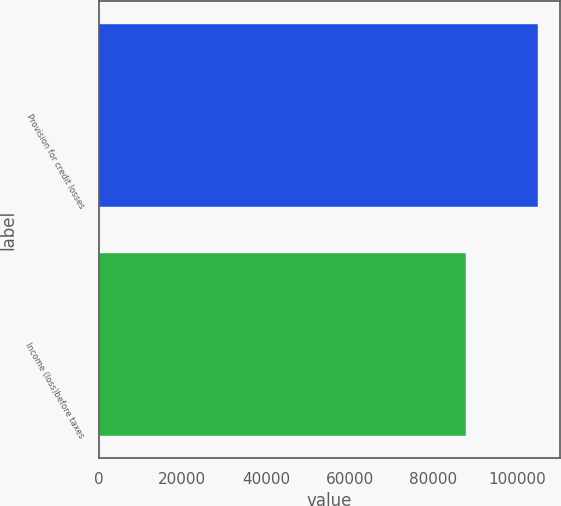<chart> <loc_0><loc_0><loc_500><loc_500><bar_chart><fcel>Provision for credit losses<fcel>Income (loss)before taxes<nl><fcel>104995<fcel>87938<nl></chart> 